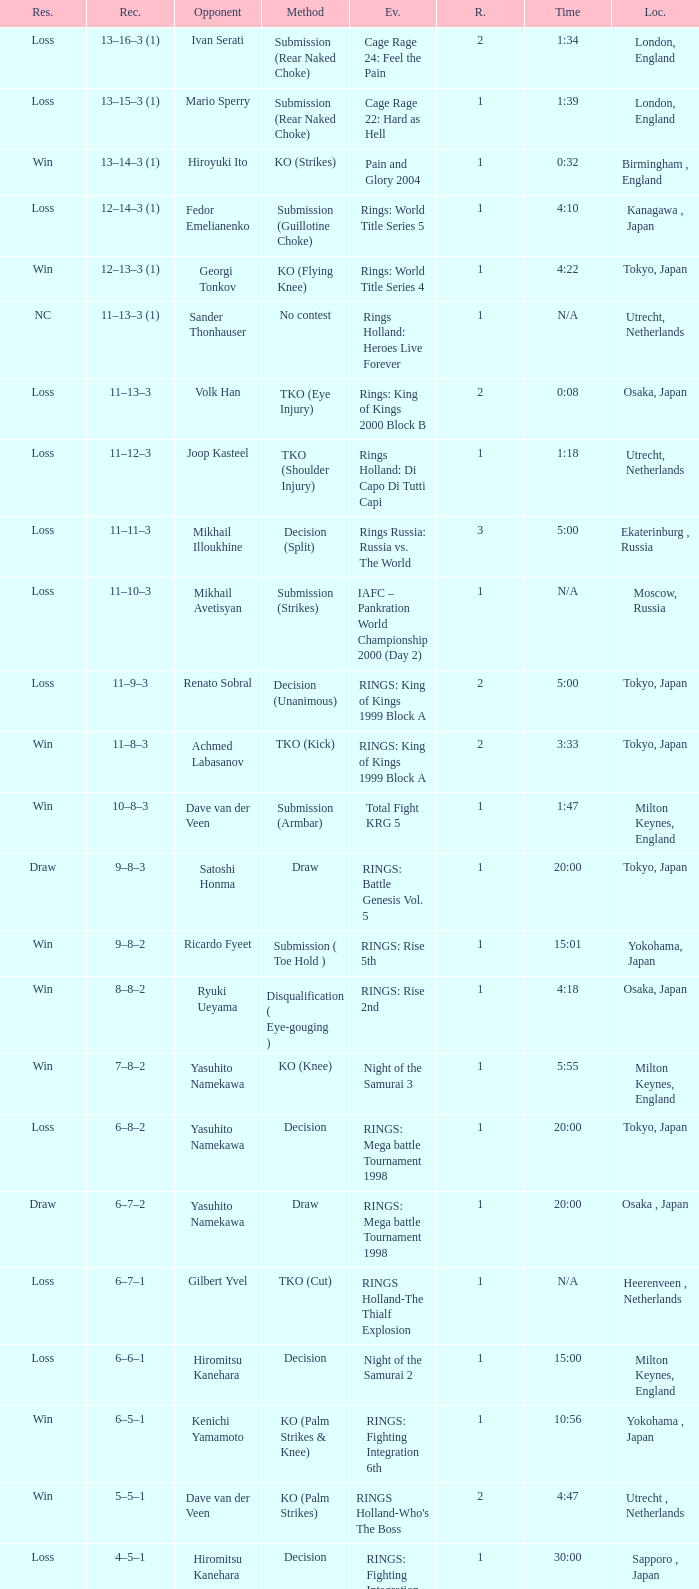What event featured yasuhito namekawa's opponent and utilized a decision method? RINGS: Mega battle Tournament 1998. 